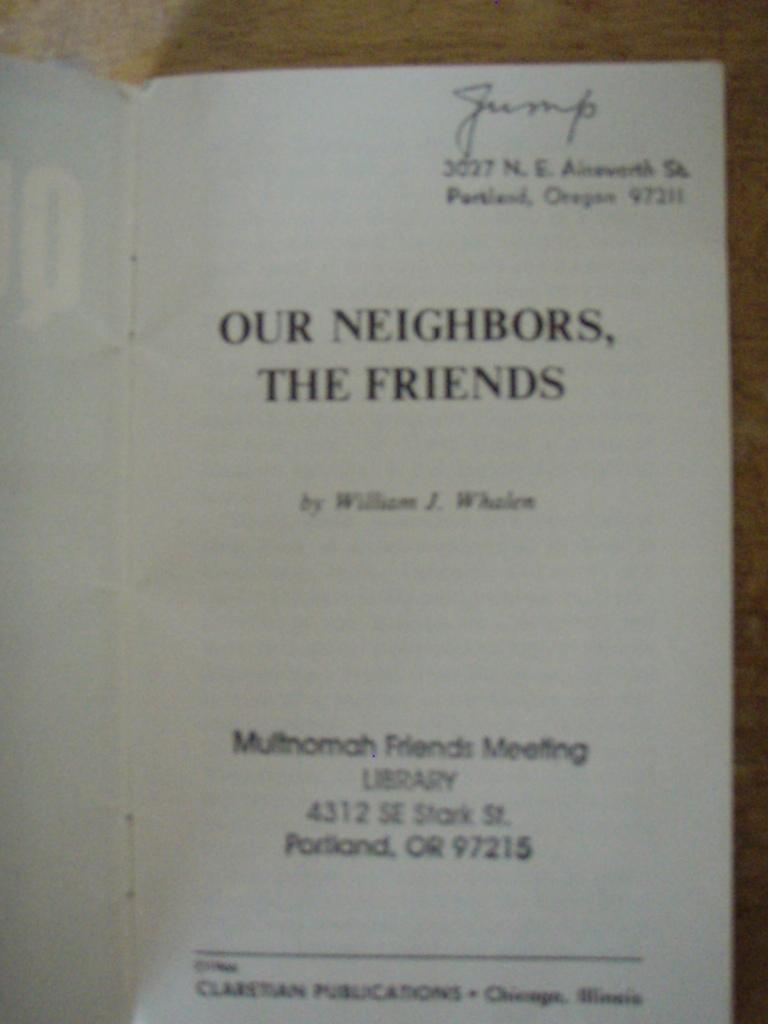Provide a one-sentence caption for the provided image. A meeting syllabus titled Our Neighbors, the Friends. 